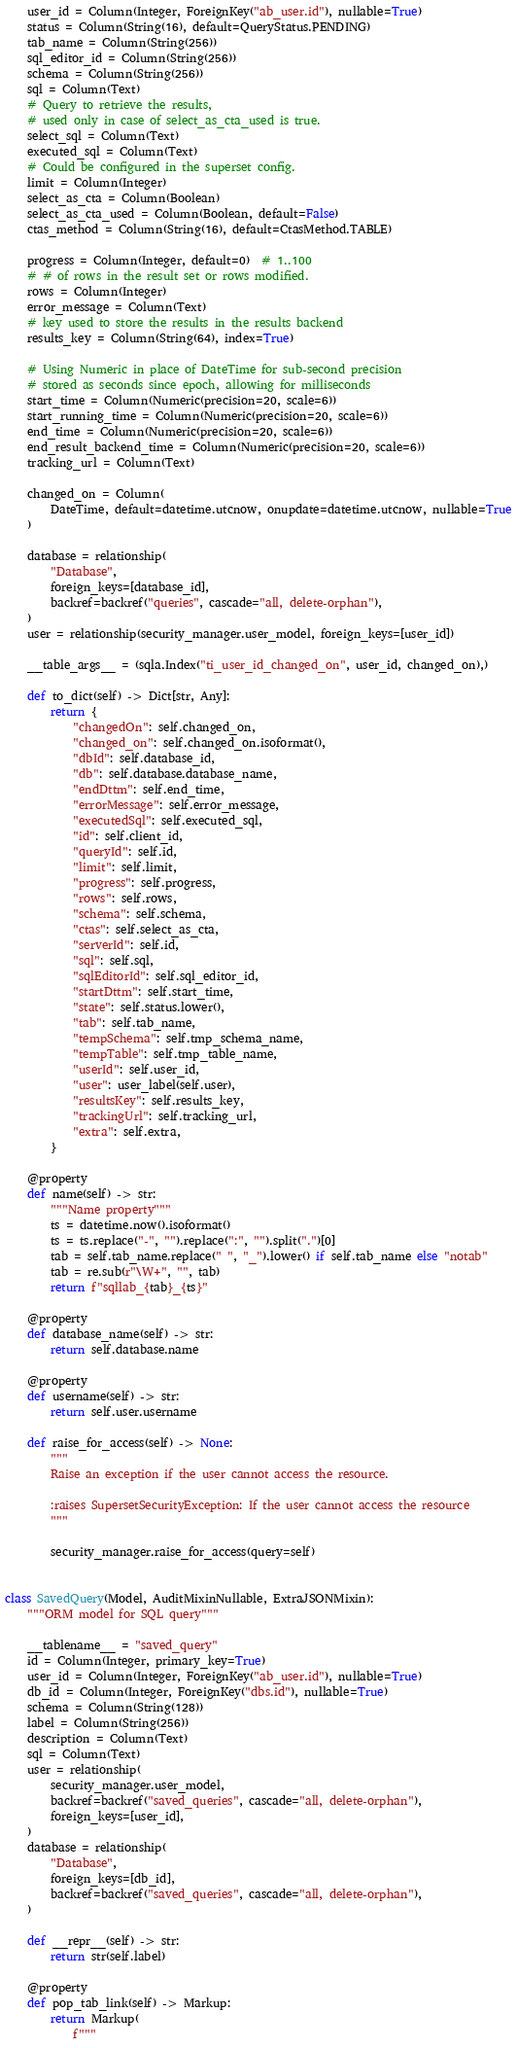Convert code to text. <code><loc_0><loc_0><loc_500><loc_500><_Python_>    user_id = Column(Integer, ForeignKey("ab_user.id"), nullable=True)
    status = Column(String(16), default=QueryStatus.PENDING)
    tab_name = Column(String(256))
    sql_editor_id = Column(String(256))
    schema = Column(String(256))
    sql = Column(Text)
    # Query to retrieve the results,
    # used only in case of select_as_cta_used is true.
    select_sql = Column(Text)
    executed_sql = Column(Text)
    # Could be configured in the superset config.
    limit = Column(Integer)
    select_as_cta = Column(Boolean)
    select_as_cta_used = Column(Boolean, default=False)
    ctas_method = Column(String(16), default=CtasMethod.TABLE)

    progress = Column(Integer, default=0)  # 1..100
    # # of rows in the result set or rows modified.
    rows = Column(Integer)
    error_message = Column(Text)
    # key used to store the results in the results backend
    results_key = Column(String(64), index=True)

    # Using Numeric in place of DateTime for sub-second precision
    # stored as seconds since epoch, allowing for milliseconds
    start_time = Column(Numeric(precision=20, scale=6))
    start_running_time = Column(Numeric(precision=20, scale=6))
    end_time = Column(Numeric(precision=20, scale=6))
    end_result_backend_time = Column(Numeric(precision=20, scale=6))
    tracking_url = Column(Text)

    changed_on = Column(
        DateTime, default=datetime.utcnow, onupdate=datetime.utcnow, nullable=True
    )

    database = relationship(
        "Database",
        foreign_keys=[database_id],
        backref=backref("queries", cascade="all, delete-orphan"),
    )
    user = relationship(security_manager.user_model, foreign_keys=[user_id])

    __table_args__ = (sqla.Index("ti_user_id_changed_on", user_id, changed_on),)

    def to_dict(self) -> Dict[str, Any]:
        return {
            "changedOn": self.changed_on,
            "changed_on": self.changed_on.isoformat(),
            "dbId": self.database_id,
            "db": self.database.database_name,
            "endDttm": self.end_time,
            "errorMessage": self.error_message,
            "executedSql": self.executed_sql,
            "id": self.client_id,
            "queryId": self.id,
            "limit": self.limit,
            "progress": self.progress,
            "rows": self.rows,
            "schema": self.schema,
            "ctas": self.select_as_cta,
            "serverId": self.id,
            "sql": self.sql,
            "sqlEditorId": self.sql_editor_id,
            "startDttm": self.start_time,
            "state": self.status.lower(),
            "tab": self.tab_name,
            "tempSchema": self.tmp_schema_name,
            "tempTable": self.tmp_table_name,
            "userId": self.user_id,
            "user": user_label(self.user),
            "resultsKey": self.results_key,
            "trackingUrl": self.tracking_url,
            "extra": self.extra,
        }

    @property
    def name(self) -> str:
        """Name property"""
        ts = datetime.now().isoformat()
        ts = ts.replace("-", "").replace(":", "").split(".")[0]
        tab = self.tab_name.replace(" ", "_").lower() if self.tab_name else "notab"
        tab = re.sub(r"\W+", "", tab)
        return f"sqllab_{tab}_{ts}"

    @property
    def database_name(self) -> str:
        return self.database.name

    @property
    def username(self) -> str:
        return self.user.username

    def raise_for_access(self) -> None:
        """
        Raise an exception if the user cannot access the resource.

        :raises SupersetSecurityException: If the user cannot access the resource
        """

        security_manager.raise_for_access(query=self)


class SavedQuery(Model, AuditMixinNullable, ExtraJSONMixin):
    """ORM model for SQL query"""

    __tablename__ = "saved_query"
    id = Column(Integer, primary_key=True)
    user_id = Column(Integer, ForeignKey("ab_user.id"), nullable=True)
    db_id = Column(Integer, ForeignKey("dbs.id"), nullable=True)
    schema = Column(String(128))
    label = Column(String(256))
    description = Column(Text)
    sql = Column(Text)
    user = relationship(
        security_manager.user_model,
        backref=backref("saved_queries", cascade="all, delete-orphan"),
        foreign_keys=[user_id],
    )
    database = relationship(
        "Database",
        foreign_keys=[db_id],
        backref=backref("saved_queries", cascade="all, delete-orphan"),
    )

    def __repr__(self) -> str:
        return str(self.label)

    @property
    def pop_tab_link(self) -> Markup:
        return Markup(
            f"""</code> 